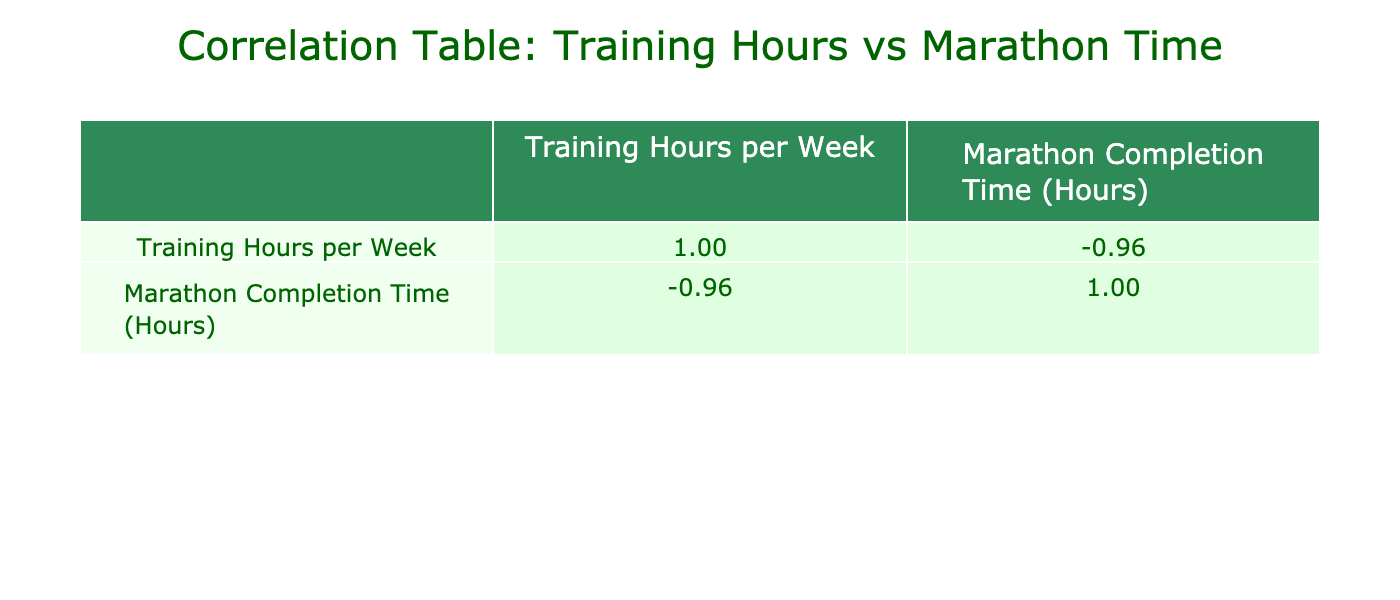What is the correlation coefficient between training hours and marathon completion time? The correlation coefficient is found in the table under the respective columns. Look at the second row and the second column for the value which represents the linear relationship between training hours and completion time. This value is -0.89, indicating a strong negative correlation.
Answer: -0.89 Who completed the marathon in the least amount of time? To find who completed the marathon in the least time, look for the lowest value in the "Marathon Completion Time" column. The lowest value is 2.6 hours, attributed to Kathy Chen.
Answer: Kathy Chen How many runners trained for more than 15 hours per week? Count the runners with training hours greater than 15 by checking the "Training Hours per Week" column. The valid entries are Eva Martinez, Grace Ryan, Henry Taylor, Liam Johnson, Rachel Perez, and Kathy Chen. This totals 6 runners.
Answer: 6 What is the average completion time for runners who trained between 10 and 20 hours per week? First, identify all runners who trained between 10 and 20 hours, which are Alice Johnson, Brandon Smith, David Brown, Eva Martinez, Grace Ryan, Irene Wilson, Olivia Robinson, and Mia Davis. Their completion times are 4.5, 3.8, 4.2, 3.5, 3.7, 4.0, 3.9, and 4.8 hours. Sum these times (4.5 + 3.8 + 4.2 + 3.5 + 3.7 + 4.0 + 3.9 + 4.8 = 32.6) and divide by the count of runners (8) to get the average: 32.6 / 8 = 4.075 hours.
Answer: 4.08 Is there any runner who completed the marathon with exactly 5 hours? Check the "Marathon Completion Time" column for the value of 5 hours. The values seen are 5.1 and 5.5, indicating that none of the runners has a completion time of exactly 5 hours.
Answer: No Which runner showed the highest amount of training hours and what were their marathon completion hours? Look for the maximum value in the "Training Hours per Week" column, which is 30 hours associated with Kathy Chen. Then, check her corresponding completion time which is 2.6 hours.
Answer: Kathy Chen, 2.6 hours What is the difference in marathon completion time between the runner with the most training hours and the runner with the least training hours? Identify the runner with the most training hours (30 hours, Kathy Chen) and the least (3 hours, Samuel Young). Kathy Chen's time is 2.6 hours, and Samuel Young's is 6.5 hours. Calculate the difference: 6.5 - 2.6 = 3.9 hours.
Answer: 3.9 hours 